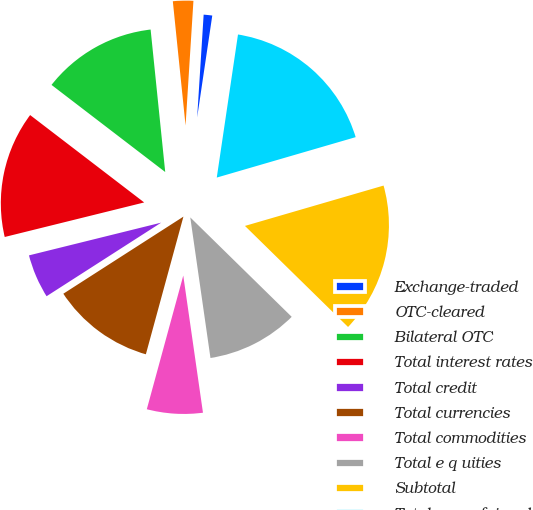<chart> <loc_0><loc_0><loc_500><loc_500><pie_chart><fcel>Exchange-traded<fcel>OTC-cleared<fcel>Bilateral OTC<fcel>Total interest rates<fcel>Total credit<fcel>Total currencies<fcel>Total commodities<fcel>Total e q uities<fcel>Subtotal<fcel>Total gross fair value<nl><fcel>1.34%<fcel>2.63%<fcel>12.97%<fcel>14.27%<fcel>5.22%<fcel>11.68%<fcel>6.51%<fcel>10.39%<fcel>16.85%<fcel>18.15%<nl></chart> 